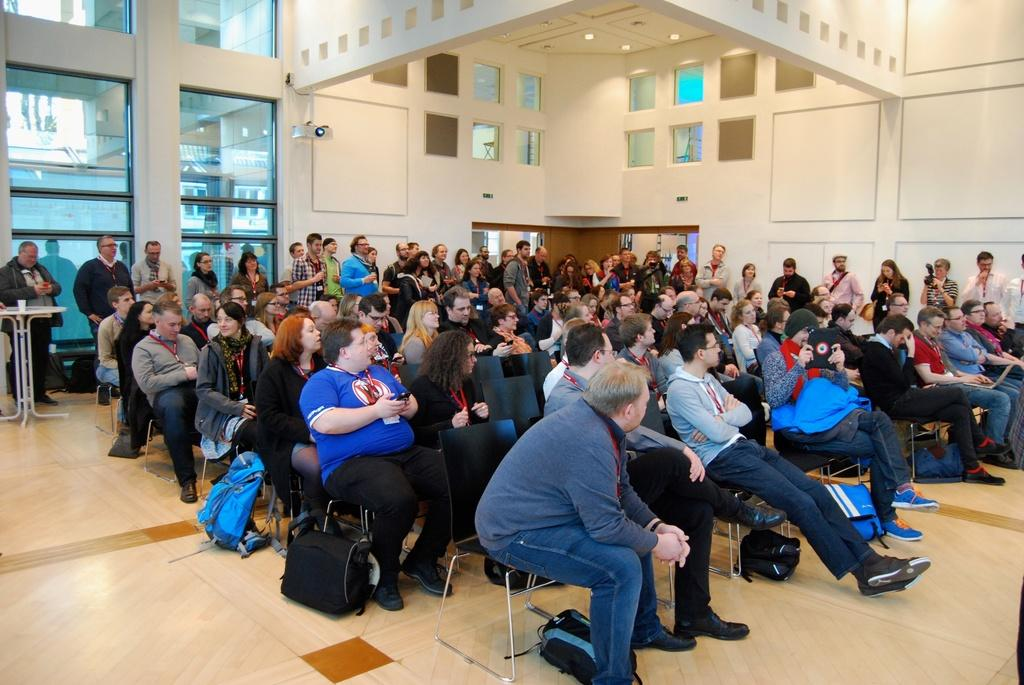What are the people in the image doing? Some people are sitting, and some are standing in the image. Can you describe any objects on a table in the image? There is a glass on a table in the image. What is on the floor in the image? There are bags on the floor in the image. What can be seen in the background of the image? There is a wall, a camera, and windows in the background of the image. What is visible at the top of the image? There are lights visible at the top of the image. What type of unit is being measured by the tongue in the image? There is no tongue or unit measurement present in the image. What is the glass being used for in the image? The glass is not being used for anything specific in the image; it is simply on the table. 